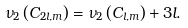<formula> <loc_0><loc_0><loc_500><loc_500>\nu _ { 2 } \left ( C _ { 2 l , m } \right ) = \nu _ { 2 } \left ( C _ { l , m } \right ) + 3 l .</formula> 